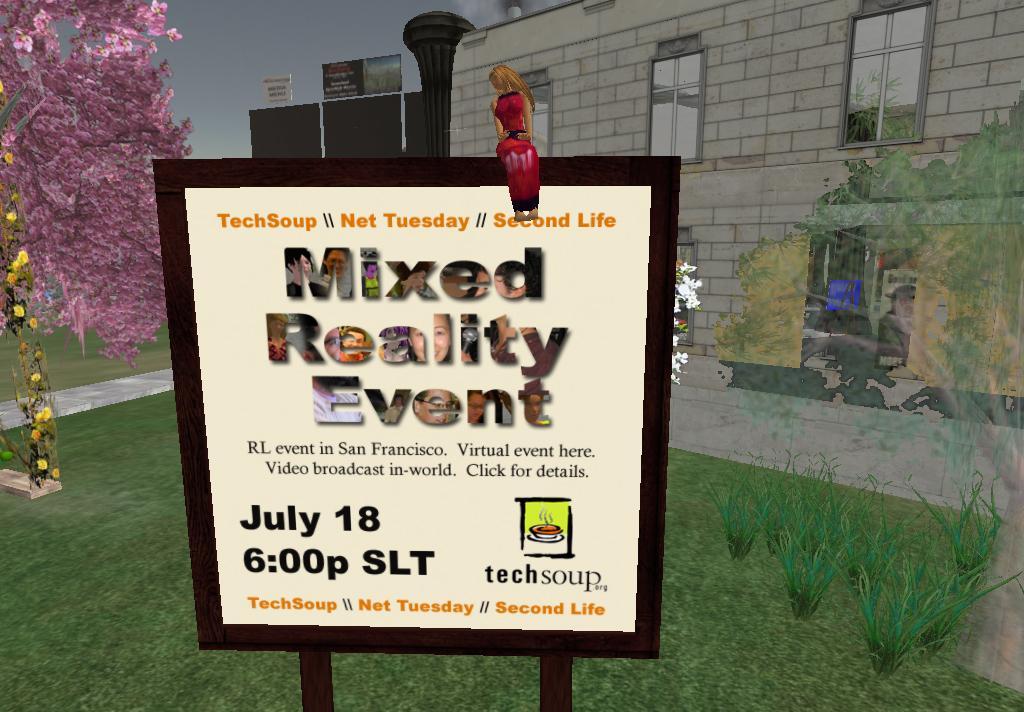Please provide a concise description of this image. This image looks like animated. In the front, there is a board. To the left, there is a tree. In the background, there is a building along with windows. At the bottom, there is green grass. 